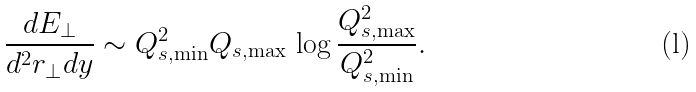Convert formula to latex. <formula><loc_0><loc_0><loc_500><loc_500>\frac { d E _ { \perp } } { d ^ { 2 } { r } _ { \perp } d y } \sim Q _ { s , \min } ^ { 2 } Q _ { s , \max } \, \log \frac { Q _ { s , \max } ^ { 2 } } { Q _ { s , \min } ^ { 2 } } .</formula> 